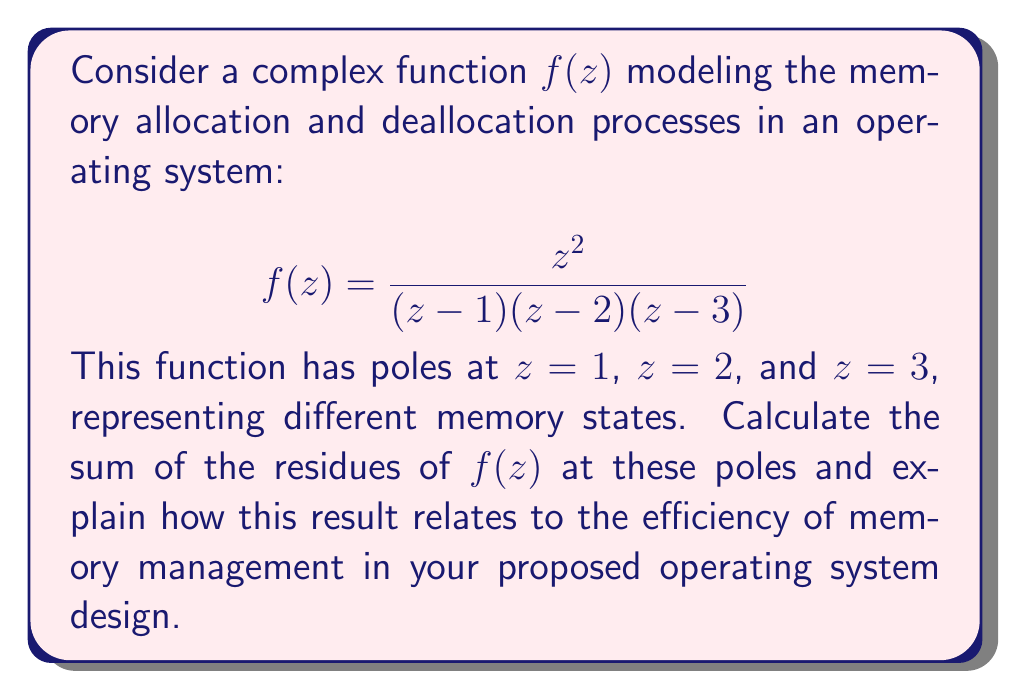Could you help me with this problem? To solve this problem, we'll use the residue theorem and calculate the residues at each pole. The residue theorem states that for a meromorphic function $f(z)$, the sum of its residues within a simply connected domain is equal to the contour integral of $f(z)$ around the boundary of that domain divided by $2\pi i$.

1. First, let's calculate the residue at $z=1$:
   $$\text{Res}(f,1) = \lim_{z \to 1} (z-1)f(z) = \lim_{z \to 1} \frac{z^2}{(z-2)(z-3)} = \frac{1}{(1-2)(1-3)} = \frac{1}{2}$$

2. Now, let's calculate the residue at $z=2$:
   $$\text{Res}(f,2) = \lim_{z \to 2} (z-2)f(z) = \lim_{z \to 2} \frac{z^2}{(z-1)(z-3)} = \frac{4}{(2-1)(2-3)} = -4$$

3. Finally, let's calculate the residue at $z=3$:
   $$\text{Res}(f,3) = \lim_{z \to 3} (z-3)f(z) = \lim_{z \to 3} \frac{z^2}{(z-1)(z-2)} = \frac{9}{(3-1)(3-2)} = \frac{9}{2}$$

4. The sum of the residues is:
   $$\text{Sum of Residues} = \frac{1}{2} + (-4) + \frac{9}{2} = 1$$

In the context of operating system design and memory management, this result can be interpreted as follows:

1. Each pole represents a different memory state or allocation process.
2. The residues at these poles indicate the relative importance or frequency of these states in the memory management system.
3. The fact that the sum of residues is 1 suggests a balanced or conservative memory management approach, where allocations and deallocations tend to balance out over time.
4. The negative residue at $z=2$ could represent a deallocation process, while the positive residues at $z=1$ and $z=3$ could represent allocation processes.
5. The larger magnitude of the residue at $z=3$ suggests that this memory state or process is more significant in the overall system behavior.

This analysis can help in designing an efficient memory allocation and deallocation strategy for the new operating system, by prioritizing the most frequent or impactful memory states and optimizing the transitions between them.
Answer: The sum of the residues of $f(z)$ at its poles is 1. This result suggests a balanced memory management approach in the proposed operating system design, where memory allocations and deallocations tend to equilibrate over time, potentially leading to efficient memory utilization. 